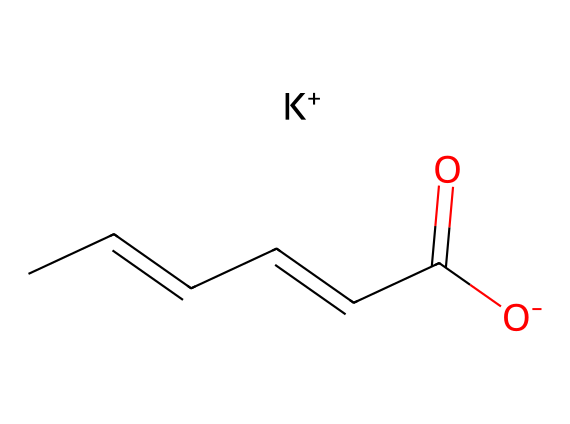What is the molecular formula of potassium sorbate? The SMILES representation reveals the components of the molecule. The presence of carbon (C), hydrogen (H), oxygen (O), and potassium (K) atoms indicates its molecular formula is C6H7O2K.
Answer: C6H7O2K How many carbon atoms are in potassium sorbate? By analyzing the SMILES notation, we see that the root structure contains six carbon (C) atoms.
Answer: 6 What type of bond connects the carbon atoms in the carbon chain? The carbon atoms in the chain are connected by double bonds, as indicated by the '=' sign between some of the carbon atoms in the SMILES.
Answer: double bonds Which part of the molecule is responsible for its preservative properties? The carboxylate group (−COO−) is responsible for the preservative properties, as these groups are effective in inhibiting microbial growth.
Answer: carboxylate group What is the charge of the potassium ion in potassium sorbate? The SMILES representation shows '[K+]', indicating that the potassium ion has a positive charge.
Answer: positive How many oxygen atoms are present in potassium sorbate? In the molecular structure derived from the SMILES, there are two oxygen (O) atoms visible in the carboxylate group.
Answer: 2 Is potassium sorbate a solid or liquid at room temperature? Given that potassium sorbate is commonly used as a preservative, it is typically found in solid form at room temperature, as indicated by its application in food and document preservation.
Answer: solid 